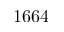<formula> <loc_0><loc_0><loc_500><loc_500>1 6 6 4</formula> 